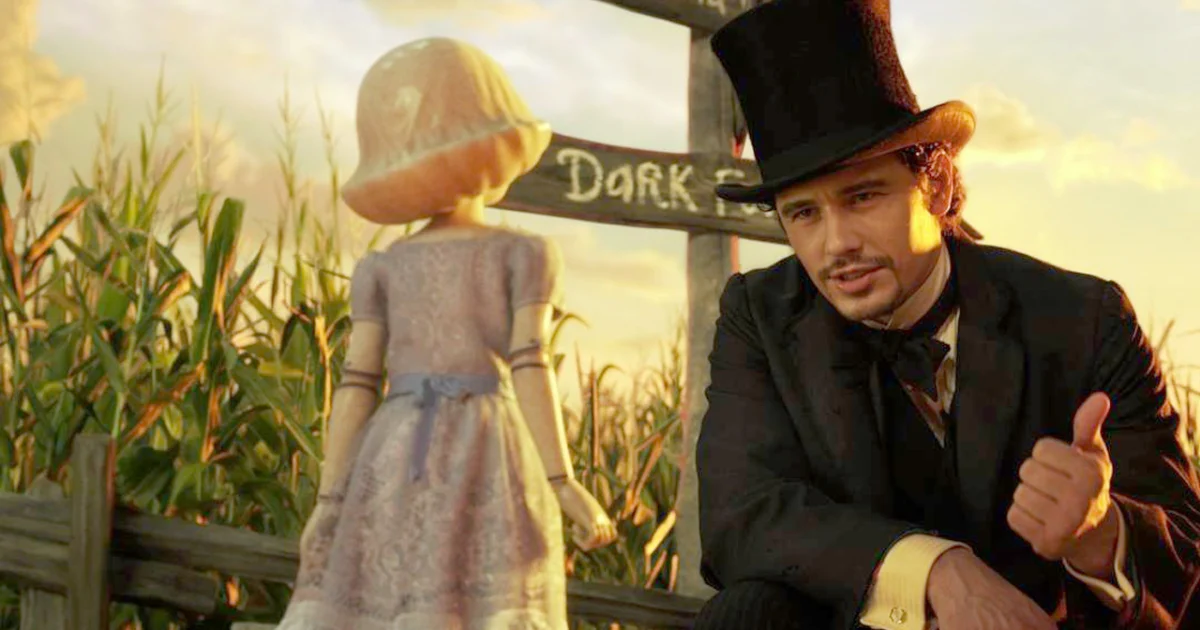What do you think is going on in this snapshot? The image features a poignant scene from the movie 'Oz the Great and Powerful'. Here, James Franco, dressed as the character Oz, engages with the China Girl, a delicate, doll-like figure. They are in a vibrantly colored cornfield at sunset, creating a surreal, almost magical atmosphere. Oz, in his dark suit and top hat, contrasts sharply with the lighter colors of the setting and China Girl's attire. The sign reading 'Dark' might hint at the darker undertones or challenges the characters face in the story. This snapshot captures a moment of connection and dialogue between the two, possibly exploring themes of trust and friendship in the narrative. 